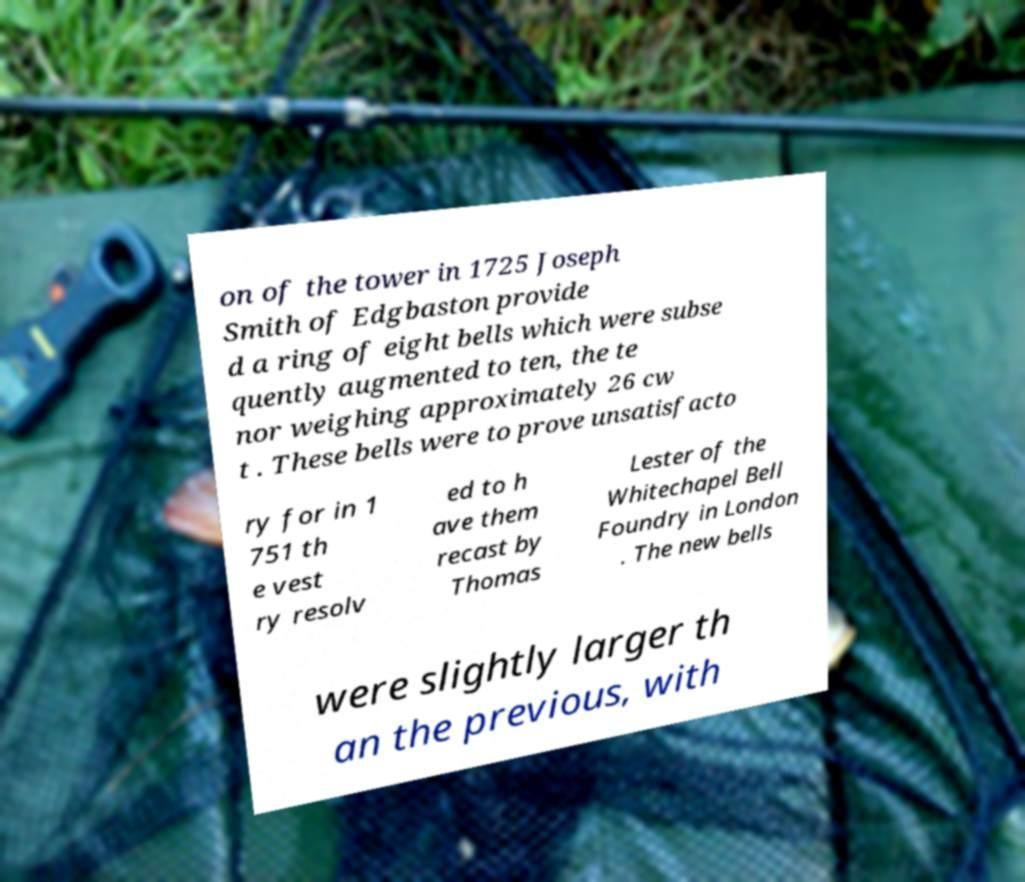Can you read and provide the text displayed in the image?This photo seems to have some interesting text. Can you extract and type it out for me? on of the tower in 1725 Joseph Smith of Edgbaston provide d a ring of eight bells which were subse quently augmented to ten, the te nor weighing approximately 26 cw t . These bells were to prove unsatisfacto ry for in 1 751 th e vest ry resolv ed to h ave them recast by Thomas Lester of the Whitechapel Bell Foundry in London . The new bells were slightly larger th an the previous, with 